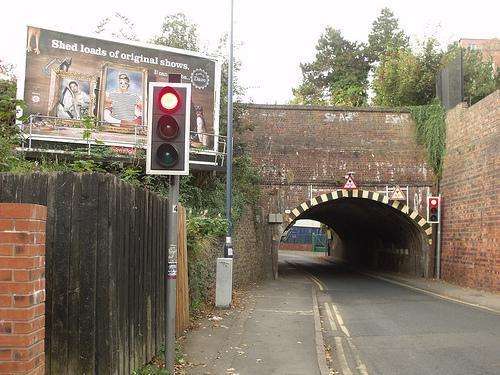How many billboards are visible?
Give a very brief answer. 1. 